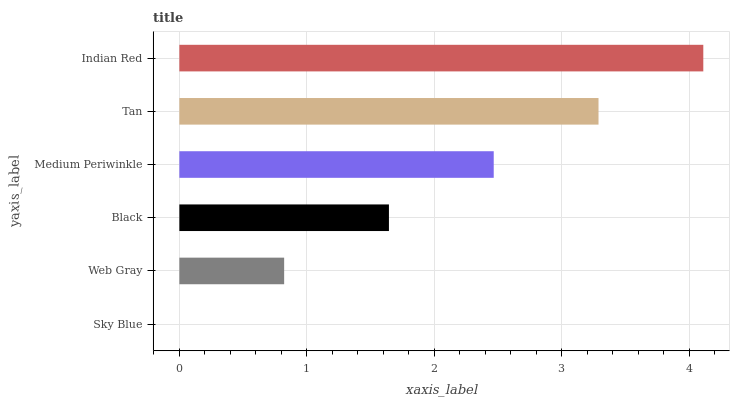Is Sky Blue the minimum?
Answer yes or no. Yes. Is Indian Red the maximum?
Answer yes or no. Yes. Is Web Gray the minimum?
Answer yes or no. No. Is Web Gray the maximum?
Answer yes or no. No. Is Web Gray greater than Sky Blue?
Answer yes or no. Yes. Is Sky Blue less than Web Gray?
Answer yes or no. Yes. Is Sky Blue greater than Web Gray?
Answer yes or no. No. Is Web Gray less than Sky Blue?
Answer yes or no. No. Is Medium Periwinkle the high median?
Answer yes or no. Yes. Is Black the low median?
Answer yes or no. Yes. Is Black the high median?
Answer yes or no. No. Is Medium Periwinkle the low median?
Answer yes or no. No. 